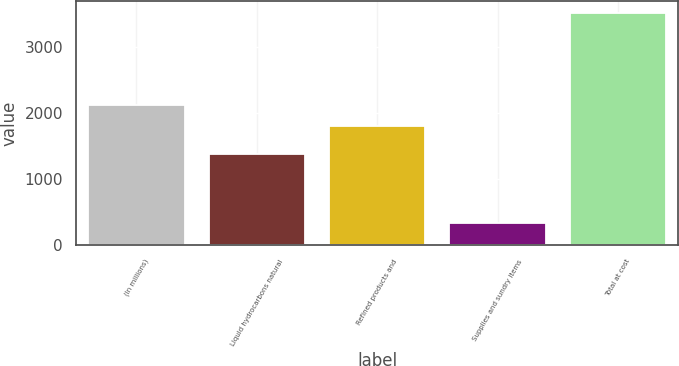Convert chart. <chart><loc_0><loc_0><loc_500><loc_500><bar_chart><fcel>(In millions)<fcel>Liquid hydrocarbons natural<fcel>Refined products and<fcel>Supplies and sundry items<fcel>Total at cost<nl><fcel>2114.3<fcel>1376<fcel>1797<fcel>334<fcel>3507<nl></chart> 